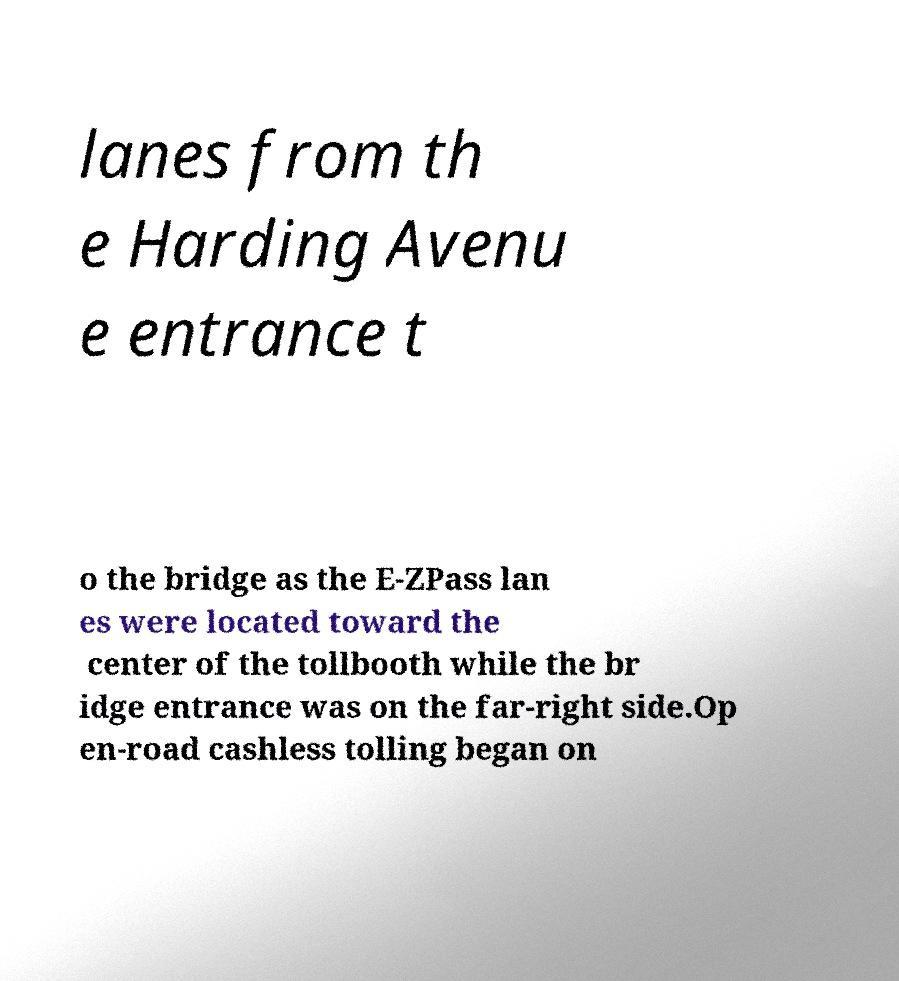What messages or text are displayed in this image? I need them in a readable, typed format. lanes from th e Harding Avenu e entrance t o the bridge as the E-ZPass lan es were located toward the center of the tollbooth while the br idge entrance was on the far-right side.Op en-road cashless tolling began on 